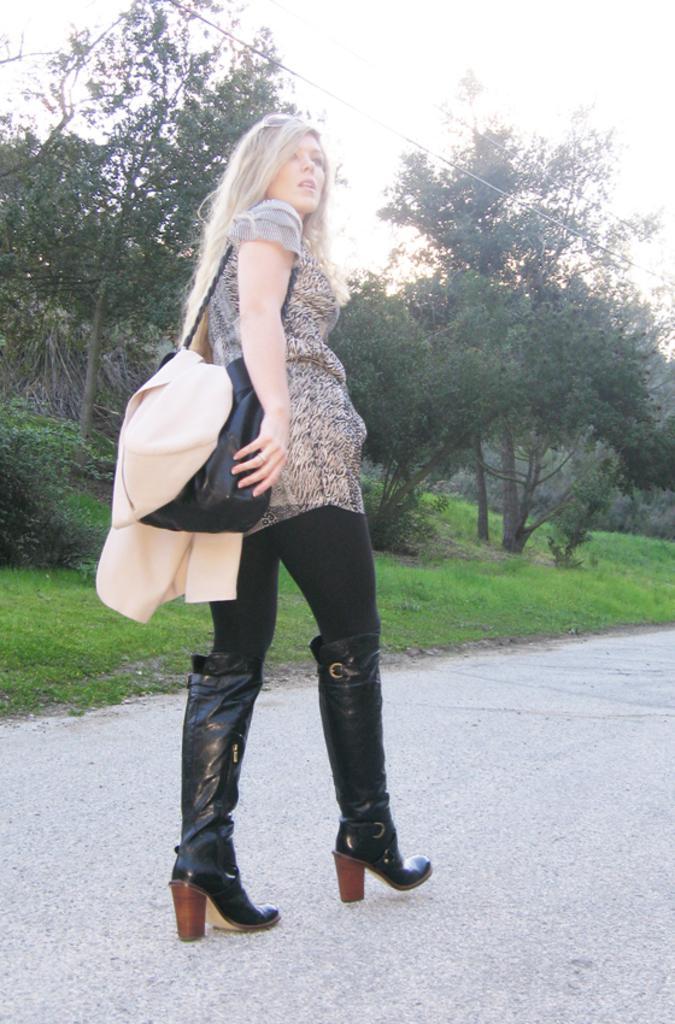Describe this image in one or two sentences. In this image, woman is walking on a road. Here we can see green grass. And background, we can see few plants and sky, wire. Woman is wearing a black color bag and here we can see cream color cloth. 